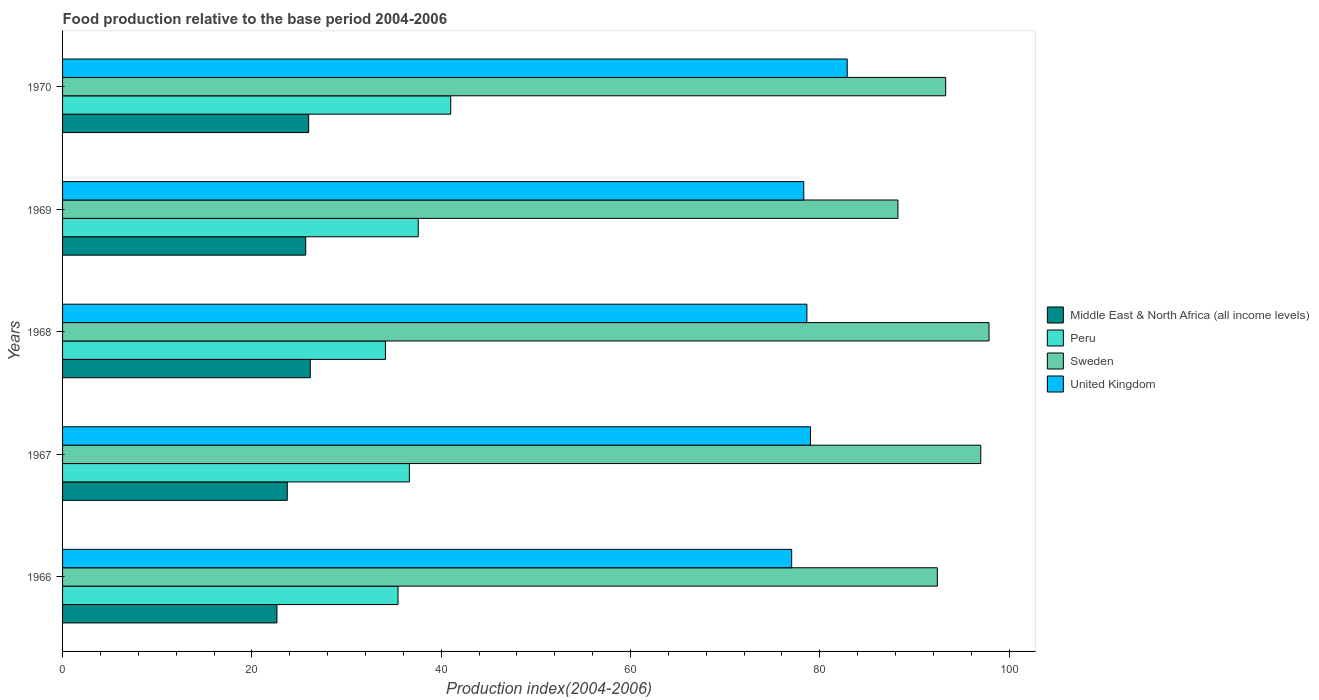Are the number of bars per tick equal to the number of legend labels?
Your answer should be very brief. Yes. Are the number of bars on each tick of the Y-axis equal?
Your response must be concise. Yes. How many bars are there on the 4th tick from the top?
Make the answer very short. 4. How many bars are there on the 2nd tick from the bottom?
Offer a very short reply. 4. What is the label of the 4th group of bars from the top?
Provide a succinct answer. 1967. What is the food production index in Peru in 1967?
Your response must be concise. 36.64. Across all years, what is the maximum food production index in Sweden?
Your response must be concise. 97.88. Across all years, what is the minimum food production index in Sweden?
Provide a succinct answer. 88.26. In which year was the food production index in Middle East & North Africa (all income levels) maximum?
Ensure brevity in your answer.  1968. In which year was the food production index in Sweden minimum?
Your answer should be compact. 1969. What is the total food production index in United Kingdom in the graph?
Your answer should be compact. 395.9. What is the difference between the food production index in Peru in 1966 and that in 1968?
Offer a very short reply. 1.33. What is the difference between the food production index in Peru in 1966 and the food production index in Sweden in 1967?
Ensure brevity in your answer.  -61.57. What is the average food production index in Peru per year?
Give a very brief answer. 36.96. In the year 1968, what is the difference between the food production index in United Kingdom and food production index in Sweden?
Give a very brief answer. -19.24. What is the ratio of the food production index in United Kingdom in 1967 to that in 1969?
Offer a terse response. 1.01. Is the difference between the food production index in United Kingdom in 1968 and 1969 greater than the difference between the food production index in Sweden in 1968 and 1969?
Offer a terse response. No. What is the difference between the highest and the second highest food production index in Middle East & North Africa (all income levels)?
Keep it short and to the point. 0.17. What is the difference between the highest and the lowest food production index in Peru?
Ensure brevity in your answer.  6.9. In how many years, is the food production index in United Kingdom greater than the average food production index in United Kingdom taken over all years?
Offer a very short reply. 1. Is the sum of the food production index in United Kingdom in 1966 and 1969 greater than the maximum food production index in Middle East & North Africa (all income levels) across all years?
Provide a short and direct response. Yes. What does the 3rd bar from the bottom in 1970 represents?
Your answer should be very brief. Sweden. How many bars are there?
Your response must be concise. 20. Are all the bars in the graph horizontal?
Provide a short and direct response. Yes. How many years are there in the graph?
Ensure brevity in your answer.  5. What is the difference between two consecutive major ticks on the X-axis?
Provide a succinct answer. 20. Does the graph contain any zero values?
Offer a terse response. No. How many legend labels are there?
Offer a very short reply. 4. What is the title of the graph?
Provide a short and direct response. Food production relative to the base period 2004-2006. Does "Palau" appear as one of the legend labels in the graph?
Your answer should be compact. No. What is the label or title of the X-axis?
Your answer should be very brief. Production index(2004-2006). What is the Production index(2004-2006) of Middle East & North Africa (all income levels) in 1966?
Make the answer very short. 22.65. What is the Production index(2004-2006) in Peru in 1966?
Make the answer very short. 35.44. What is the Production index(2004-2006) in Sweden in 1966?
Your answer should be very brief. 92.42. What is the Production index(2004-2006) in United Kingdom in 1966?
Offer a terse response. 77.03. What is the Production index(2004-2006) in Middle East & North Africa (all income levels) in 1967?
Offer a terse response. 23.74. What is the Production index(2004-2006) of Peru in 1967?
Your answer should be compact. 36.64. What is the Production index(2004-2006) of Sweden in 1967?
Provide a short and direct response. 97.01. What is the Production index(2004-2006) of United Kingdom in 1967?
Ensure brevity in your answer.  79.02. What is the Production index(2004-2006) of Middle East & North Africa (all income levels) in 1968?
Ensure brevity in your answer.  26.17. What is the Production index(2004-2006) in Peru in 1968?
Provide a succinct answer. 34.11. What is the Production index(2004-2006) in Sweden in 1968?
Your response must be concise. 97.88. What is the Production index(2004-2006) in United Kingdom in 1968?
Your response must be concise. 78.64. What is the Production index(2004-2006) in Middle East & North Africa (all income levels) in 1969?
Provide a succinct answer. 25.69. What is the Production index(2004-2006) of Peru in 1969?
Offer a very short reply. 37.58. What is the Production index(2004-2006) of Sweden in 1969?
Offer a very short reply. 88.26. What is the Production index(2004-2006) in United Kingdom in 1969?
Provide a short and direct response. 78.31. What is the Production index(2004-2006) in Middle East & North Africa (all income levels) in 1970?
Keep it short and to the point. 26. What is the Production index(2004-2006) in Peru in 1970?
Offer a very short reply. 41.01. What is the Production index(2004-2006) of Sweden in 1970?
Make the answer very short. 93.3. What is the Production index(2004-2006) in United Kingdom in 1970?
Give a very brief answer. 82.9. Across all years, what is the maximum Production index(2004-2006) in Middle East & North Africa (all income levels)?
Provide a short and direct response. 26.17. Across all years, what is the maximum Production index(2004-2006) in Peru?
Give a very brief answer. 41.01. Across all years, what is the maximum Production index(2004-2006) in Sweden?
Give a very brief answer. 97.88. Across all years, what is the maximum Production index(2004-2006) of United Kingdom?
Your answer should be compact. 82.9. Across all years, what is the minimum Production index(2004-2006) of Middle East & North Africa (all income levels)?
Give a very brief answer. 22.65. Across all years, what is the minimum Production index(2004-2006) of Peru?
Your response must be concise. 34.11. Across all years, what is the minimum Production index(2004-2006) in Sweden?
Make the answer very short. 88.26. Across all years, what is the minimum Production index(2004-2006) of United Kingdom?
Your answer should be compact. 77.03. What is the total Production index(2004-2006) in Middle East & North Africa (all income levels) in the graph?
Ensure brevity in your answer.  124.25. What is the total Production index(2004-2006) in Peru in the graph?
Offer a very short reply. 184.78. What is the total Production index(2004-2006) of Sweden in the graph?
Provide a succinct answer. 468.87. What is the total Production index(2004-2006) of United Kingdom in the graph?
Offer a terse response. 395.9. What is the difference between the Production index(2004-2006) in Middle East & North Africa (all income levels) in 1966 and that in 1967?
Ensure brevity in your answer.  -1.09. What is the difference between the Production index(2004-2006) of Sweden in 1966 and that in 1967?
Your answer should be compact. -4.59. What is the difference between the Production index(2004-2006) of United Kingdom in 1966 and that in 1967?
Your answer should be very brief. -1.99. What is the difference between the Production index(2004-2006) of Middle East & North Africa (all income levels) in 1966 and that in 1968?
Offer a very short reply. -3.52. What is the difference between the Production index(2004-2006) of Peru in 1966 and that in 1968?
Ensure brevity in your answer.  1.33. What is the difference between the Production index(2004-2006) of Sweden in 1966 and that in 1968?
Make the answer very short. -5.46. What is the difference between the Production index(2004-2006) in United Kingdom in 1966 and that in 1968?
Provide a short and direct response. -1.61. What is the difference between the Production index(2004-2006) of Middle East & North Africa (all income levels) in 1966 and that in 1969?
Offer a very short reply. -3.04. What is the difference between the Production index(2004-2006) of Peru in 1966 and that in 1969?
Your answer should be very brief. -2.14. What is the difference between the Production index(2004-2006) in Sweden in 1966 and that in 1969?
Your response must be concise. 4.16. What is the difference between the Production index(2004-2006) of United Kingdom in 1966 and that in 1969?
Provide a succinct answer. -1.28. What is the difference between the Production index(2004-2006) in Middle East & North Africa (all income levels) in 1966 and that in 1970?
Keep it short and to the point. -3.35. What is the difference between the Production index(2004-2006) of Peru in 1966 and that in 1970?
Your answer should be very brief. -5.57. What is the difference between the Production index(2004-2006) of Sweden in 1966 and that in 1970?
Make the answer very short. -0.88. What is the difference between the Production index(2004-2006) of United Kingdom in 1966 and that in 1970?
Keep it short and to the point. -5.87. What is the difference between the Production index(2004-2006) of Middle East & North Africa (all income levels) in 1967 and that in 1968?
Your answer should be compact. -2.43. What is the difference between the Production index(2004-2006) of Peru in 1967 and that in 1968?
Offer a very short reply. 2.53. What is the difference between the Production index(2004-2006) in Sweden in 1967 and that in 1968?
Your answer should be compact. -0.87. What is the difference between the Production index(2004-2006) of United Kingdom in 1967 and that in 1968?
Your answer should be compact. 0.38. What is the difference between the Production index(2004-2006) of Middle East & North Africa (all income levels) in 1967 and that in 1969?
Keep it short and to the point. -1.95. What is the difference between the Production index(2004-2006) in Peru in 1967 and that in 1969?
Provide a succinct answer. -0.94. What is the difference between the Production index(2004-2006) of Sweden in 1967 and that in 1969?
Offer a very short reply. 8.75. What is the difference between the Production index(2004-2006) of United Kingdom in 1967 and that in 1969?
Ensure brevity in your answer.  0.71. What is the difference between the Production index(2004-2006) of Middle East & North Africa (all income levels) in 1967 and that in 1970?
Provide a short and direct response. -2.26. What is the difference between the Production index(2004-2006) of Peru in 1967 and that in 1970?
Provide a succinct answer. -4.37. What is the difference between the Production index(2004-2006) of Sweden in 1967 and that in 1970?
Provide a succinct answer. 3.71. What is the difference between the Production index(2004-2006) in United Kingdom in 1967 and that in 1970?
Your answer should be very brief. -3.88. What is the difference between the Production index(2004-2006) in Middle East & North Africa (all income levels) in 1968 and that in 1969?
Provide a succinct answer. 0.48. What is the difference between the Production index(2004-2006) in Peru in 1968 and that in 1969?
Provide a succinct answer. -3.47. What is the difference between the Production index(2004-2006) in Sweden in 1968 and that in 1969?
Give a very brief answer. 9.62. What is the difference between the Production index(2004-2006) in United Kingdom in 1968 and that in 1969?
Your answer should be very brief. 0.33. What is the difference between the Production index(2004-2006) in Middle East & North Africa (all income levels) in 1968 and that in 1970?
Your answer should be compact. 0.17. What is the difference between the Production index(2004-2006) in Sweden in 1968 and that in 1970?
Offer a terse response. 4.58. What is the difference between the Production index(2004-2006) of United Kingdom in 1968 and that in 1970?
Provide a short and direct response. -4.26. What is the difference between the Production index(2004-2006) of Middle East & North Africa (all income levels) in 1969 and that in 1970?
Your answer should be compact. -0.31. What is the difference between the Production index(2004-2006) in Peru in 1969 and that in 1970?
Your answer should be compact. -3.43. What is the difference between the Production index(2004-2006) in Sweden in 1969 and that in 1970?
Give a very brief answer. -5.04. What is the difference between the Production index(2004-2006) in United Kingdom in 1969 and that in 1970?
Provide a succinct answer. -4.59. What is the difference between the Production index(2004-2006) in Middle East & North Africa (all income levels) in 1966 and the Production index(2004-2006) in Peru in 1967?
Keep it short and to the point. -13.99. What is the difference between the Production index(2004-2006) of Middle East & North Africa (all income levels) in 1966 and the Production index(2004-2006) of Sweden in 1967?
Provide a succinct answer. -74.36. What is the difference between the Production index(2004-2006) of Middle East & North Africa (all income levels) in 1966 and the Production index(2004-2006) of United Kingdom in 1967?
Your response must be concise. -56.37. What is the difference between the Production index(2004-2006) of Peru in 1966 and the Production index(2004-2006) of Sweden in 1967?
Make the answer very short. -61.57. What is the difference between the Production index(2004-2006) in Peru in 1966 and the Production index(2004-2006) in United Kingdom in 1967?
Provide a succinct answer. -43.58. What is the difference between the Production index(2004-2006) of Middle East & North Africa (all income levels) in 1966 and the Production index(2004-2006) of Peru in 1968?
Your response must be concise. -11.46. What is the difference between the Production index(2004-2006) in Middle East & North Africa (all income levels) in 1966 and the Production index(2004-2006) in Sweden in 1968?
Your response must be concise. -75.23. What is the difference between the Production index(2004-2006) of Middle East & North Africa (all income levels) in 1966 and the Production index(2004-2006) of United Kingdom in 1968?
Give a very brief answer. -55.99. What is the difference between the Production index(2004-2006) in Peru in 1966 and the Production index(2004-2006) in Sweden in 1968?
Provide a short and direct response. -62.44. What is the difference between the Production index(2004-2006) of Peru in 1966 and the Production index(2004-2006) of United Kingdom in 1968?
Offer a very short reply. -43.2. What is the difference between the Production index(2004-2006) of Sweden in 1966 and the Production index(2004-2006) of United Kingdom in 1968?
Provide a succinct answer. 13.78. What is the difference between the Production index(2004-2006) of Middle East & North Africa (all income levels) in 1966 and the Production index(2004-2006) of Peru in 1969?
Ensure brevity in your answer.  -14.93. What is the difference between the Production index(2004-2006) in Middle East & North Africa (all income levels) in 1966 and the Production index(2004-2006) in Sweden in 1969?
Give a very brief answer. -65.61. What is the difference between the Production index(2004-2006) in Middle East & North Africa (all income levels) in 1966 and the Production index(2004-2006) in United Kingdom in 1969?
Provide a short and direct response. -55.66. What is the difference between the Production index(2004-2006) of Peru in 1966 and the Production index(2004-2006) of Sweden in 1969?
Your answer should be compact. -52.82. What is the difference between the Production index(2004-2006) in Peru in 1966 and the Production index(2004-2006) in United Kingdom in 1969?
Your answer should be very brief. -42.87. What is the difference between the Production index(2004-2006) of Sweden in 1966 and the Production index(2004-2006) of United Kingdom in 1969?
Your response must be concise. 14.11. What is the difference between the Production index(2004-2006) in Middle East & North Africa (all income levels) in 1966 and the Production index(2004-2006) in Peru in 1970?
Give a very brief answer. -18.36. What is the difference between the Production index(2004-2006) in Middle East & North Africa (all income levels) in 1966 and the Production index(2004-2006) in Sweden in 1970?
Offer a very short reply. -70.65. What is the difference between the Production index(2004-2006) of Middle East & North Africa (all income levels) in 1966 and the Production index(2004-2006) of United Kingdom in 1970?
Provide a short and direct response. -60.25. What is the difference between the Production index(2004-2006) of Peru in 1966 and the Production index(2004-2006) of Sweden in 1970?
Give a very brief answer. -57.86. What is the difference between the Production index(2004-2006) in Peru in 1966 and the Production index(2004-2006) in United Kingdom in 1970?
Offer a terse response. -47.46. What is the difference between the Production index(2004-2006) of Sweden in 1966 and the Production index(2004-2006) of United Kingdom in 1970?
Provide a succinct answer. 9.52. What is the difference between the Production index(2004-2006) of Middle East & North Africa (all income levels) in 1967 and the Production index(2004-2006) of Peru in 1968?
Provide a short and direct response. -10.37. What is the difference between the Production index(2004-2006) of Middle East & North Africa (all income levels) in 1967 and the Production index(2004-2006) of Sweden in 1968?
Make the answer very short. -74.14. What is the difference between the Production index(2004-2006) of Middle East & North Africa (all income levels) in 1967 and the Production index(2004-2006) of United Kingdom in 1968?
Your answer should be compact. -54.9. What is the difference between the Production index(2004-2006) of Peru in 1967 and the Production index(2004-2006) of Sweden in 1968?
Your response must be concise. -61.24. What is the difference between the Production index(2004-2006) in Peru in 1967 and the Production index(2004-2006) in United Kingdom in 1968?
Offer a terse response. -42. What is the difference between the Production index(2004-2006) of Sweden in 1967 and the Production index(2004-2006) of United Kingdom in 1968?
Provide a succinct answer. 18.37. What is the difference between the Production index(2004-2006) in Middle East & North Africa (all income levels) in 1967 and the Production index(2004-2006) in Peru in 1969?
Your response must be concise. -13.84. What is the difference between the Production index(2004-2006) of Middle East & North Africa (all income levels) in 1967 and the Production index(2004-2006) of Sweden in 1969?
Provide a short and direct response. -64.52. What is the difference between the Production index(2004-2006) in Middle East & North Africa (all income levels) in 1967 and the Production index(2004-2006) in United Kingdom in 1969?
Your answer should be compact. -54.57. What is the difference between the Production index(2004-2006) in Peru in 1967 and the Production index(2004-2006) in Sweden in 1969?
Ensure brevity in your answer.  -51.62. What is the difference between the Production index(2004-2006) of Peru in 1967 and the Production index(2004-2006) of United Kingdom in 1969?
Keep it short and to the point. -41.67. What is the difference between the Production index(2004-2006) of Sweden in 1967 and the Production index(2004-2006) of United Kingdom in 1969?
Ensure brevity in your answer.  18.7. What is the difference between the Production index(2004-2006) of Middle East & North Africa (all income levels) in 1967 and the Production index(2004-2006) of Peru in 1970?
Provide a succinct answer. -17.27. What is the difference between the Production index(2004-2006) of Middle East & North Africa (all income levels) in 1967 and the Production index(2004-2006) of Sweden in 1970?
Your answer should be compact. -69.56. What is the difference between the Production index(2004-2006) in Middle East & North Africa (all income levels) in 1967 and the Production index(2004-2006) in United Kingdom in 1970?
Make the answer very short. -59.16. What is the difference between the Production index(2004-2006) in Peru in 1967 and the Production index(2004-2006) in Sweden in 1970?
Make the answer very short. -56.66. What is the difference between the Production index(2004-2006) in Peru in 1967 and the Production index(2004-2006) in United Kingdom in 1970?
Provide a succinct answer. -46.26. What is the difference between the Production index(2004-2006) of Sweden in 1967 and the Production index(2004-2006) of United Kingdom in 1970?
Give a very brief answer. 14.11. What is the difference between the Production index(2004-2006) in Middle East & North Africa (all income levels) in 1968 and the Production index(2004-2006) in Peru in 1969?
Your response must be concise. -11.41. What is the difference between the Production index(2004-2006) of Middle East & North Africa (all income levels) in 1968 and the Production index(2004-2006) of Sweden in 1969?
Offer a very short reply. -62.09. What is the difference between the Production index(2004-2006) in Middle East & North Africa (all income levels) in 1968 and the Production index(2004-2006) in United Kingdom in 1969?
Your answer should be very brief. -52.14. What is the difference between the Production index(2004-2006) of Peru in 1968 and the Production index(2004-2006) of Sweden in 1969?
Provide a short and direct response. -54.15. What is the difference between the Production index(2004-2006) of Peru in 1968 and the Production index(2004-2006) of United Kingdom in 1969?
Offer a terse response. -44.2. What is the difference between the Production index(2004-2006) in Sweden in 1968 and the Production index(2004-2006) in United Kingdom in 1969?
Your answer should be compact. 19.57. What is the difference between the Production index(2004-2006) of Middle East & North Africa (all income levels) in 1968 and the Production index(2004-2006) of Peru in 1970?
Make the answer very short. -14.84. What is the difference between the Production index(2004-2006) in Middle East & North Africa (all income levels) in 1968 and the Production index(2004-2006) in Sweden in 1970?
Provide a short and direct response. -67.13. What is the difference between the Production index(2004-2006) of Middle East & North Africa (all income levels) in 1968 and the Production index(2004-2006) of United Kingdom in 1970?
Make the answer very short. -56.73. What is the difference between the Production index(2004-2006) in Peru in 1968 and the Production index(2004-2006) in Sweden in 1970?
Your answer should be compact. -59.19. What is the difference between the Production index(2004-2006) in Peru in 1968 and the Production index(2004-2006) in United Kingdom in 1970?
Your answer should be compact. -48.79. What is the difference between the Production index(2004-2006) of Sweden in 1968 and the Production index(2004-2006) of United Kingdom in 1970?
Your response must be concise. 14.98. What is the difference between the Production index(2004-2006) in Middle East & North Africa (all income levels) in 1969 and the Production index(2004-2006) in Peru in 1970?
Make the answer very short. -15.32. What is the difference between the Production index(2004-2006) of Middle East & North Africa (all income levels) in 1969 and the Production index(2004-2006) of Sweden in 1970?
Your response must be concise. -67.61. What is the difference between the Production index(2004-2006) of Middle East & North Africa (all income levels) in 1969 and the Production index(2004-2006) of United Kingdom in 1970?
Give a very brief answer. -57.21. What is the difference between the Production index(2004-2006) in Peru in 1969 and the Production index(2004-2006) in Sweden in 1970?
Your response must be concise. -55.72. What is the difference between the Production index(2004-2006) of Peru in 1969 and the Production index(2004-2006) of United Kingdom in 1970?
Keep it short and to the point. -45.32. What is the difference between the Production index(2004-2006) in Sweden in 1969 and the Production index(2004-2006) in United Kingdom in 1970?
Give a very brief answer. 5.36. What is the average Production index(2004-2006) in Middle East & North Africa (all income levels) per year?
Keep it short and to the point. 24.85. What is the average Production index(2004-2006) in Peru per year?
Offer a terse response. 36.96. What is the average Production index(2004-2006) in Sweden per year?
Give a very brief answer. 93.77. What is the average Production index(2004-2006) of United Kingdom per year?
Your answer should be compact. 79.18. In the year 1966, what is the difference between the Production index(2004-2006) of Middle East & North Africa (all income levels) and Production index(2004-2006) of Peru?
Give a very brief answer. -12.79. In the year 1966, what is the difference between the Production index(2004-2006) in Middle East & North Africa (all income levels) and Production index(2004-2006) in Sweden?
Ensure brevity in your answer.  -69.77. In the year 1966, what is the difference between the Production index(2004-2006) of Middle East & North Africa (all income levels) and Production index(2004-2006) of United Kingdom?
Provide a short and direct response. -54.38. In the year 1966, what is the difference between the Production index(2004-2006) in Peru and Production index(2004-2006) in Sweden?
Ensure brevity in your answer.  -56.98. In the year 1966, what is the difference between the Production index(2004-2006) of Peru and Production index(2004-2006) of United Kingdom?
Offer a terse response. -41.59. In the year 1966, what is the difference between the Production index(2004-2006) of Sweden and Production index(2004-2006) of United Kingdom?
Offer a very short reply. 15.39. In the year 1967, what is the difference between the Production index(2004-2006) of Middle East & North Africa (all income levels) and Production index(2004-2006) of Peru?
Provide a short and direct response. -12.9. In the year 1967, what is the difference between the Production index(2004-2006) in Middle East & North Africa (all income levels) and Production index(2004-2006) in Sweden?
Your answer should be compact. -73.27. In the year 1967, what is the difference between the Production index(2004-2006) in Middle East & North Africa (all income levels) and Production index(2004-2006) in United Kingdom?
Offer a very short reply. -55.28. In the year 1967, what is the difference between the Production index(2004-2006) of Peru and Production index(2004-2006) of Sweden?
Your response must be concise. -60.37. In the year 1967, what is the difference between the Production index(2004-2006) of Peru and Production index(2004-2006) of United Kingdom?
Keep it short and to the point. -42.38. In the year 1967, what is the difference between the Production index(2004-2006) in Sweden and Production index(2004-2006) in United Kingdom?
Offer a very short reply. 17.99. In the year 1968, what is the difference between the Production index(2004-2006) in Middle East & North Africa (all income levels) and Production index(2004-2006) in Peru?
Keep it short and to the point. -7.94. In the year 1968, what is the difference between the Production index(2004-2006) of Middle East & North Africa (all income levels) and Production index(2004-2006) of Sweden?
Give a very brief answer. -71.71. In the year 1968, what is the difference between the Production index(2004-2006) in Middle East & North Africa (all income levels) and Production index(2004-2006) in United Kingdom?
Provide a short and direct response. -52.47. In the year 1968, what is the difference between the Production index(2004-2006) in Peru and Production index(2004-2006) in Sweden?
Keep it short and to the point. -63.77. In the year 1968, what is the difference between the Production index(2004-2006) of Peru and Production index(2004-2006) of United Kingdom?
Make the answer very short. -44.53. In the year 1968, what is the difference between the Production index(2004-2006) in Sweden and Production index(2004-2006) in United Kingdom?
Keep it short and to the point. 19.24. In the year 1969, what is the difference between the Production index(2004-2006) in Middle East & North Africa (all income levels) and Production index(2004-2006) in Peru?
Your answer should be compact. -11.89. In the year 1969, what is the difference between the Production index(2004-2006) in Middle East & North Africa (all income levels) and Production index(2004-2006) in Sweden?
Make the answer very short. -62.57. In the year 1969, what is the difference between the Production index(2004-2006) in Middle East & North Africa (all income levels) and Production index(2004-2006) in United Kingdom?
Your answer should be compact. -52.62. In the year 1969, what is the difference between the Production index(2004-2006) of Peru and Production index(2004-2006) of Sweden?
Provide a short and direct response. -50.68. In the year 1969, what is the difference between the Production index(2004-2006) of Peru and Production index(2004-2006) of United Kingdom?
Offer a very short reply. -40.73. In the year 1969, what is the difference between the Production index(2004-2006) in Sweden and Production index(2004-2006) in United Kingdom?
Your answer should be compact. 9.95. In the year 1970, what is the difference between the Production index(2004-2006) of Middle East & North Africa (all income levels) and Production index(2004-2006) of Peru?
Offer a very short reply. -15.01. In the year 1970, what is the difference between the Production index(2004-2006) in Middle East & North Africa (all income levels) and Production index(2004-2006) in Sweden?
Your answer should be very brief. -67.3. In the year 1970, what is the difference between the Production index(2004-2006) in Middle East & North Africa (all income levels) and Production index(2004-2006) in United Kingdom?
Ensure brevity in your answer.  -56.9. In the year 1970, what is the difference between the Production index(2004-2006) in Peru and Production index(2004-2006) in Sweden?
Provide a succinct answer. -52.29. In the year 1970, what is the difference between the Production index(2004-2006) in Peru and Production index(2004-2006) in United Kingdom?
Offer a very short reply. -41.89. What is the ratio of the Production index(2004-2006) in Middle East & North Africa (all income levels) in 1966 to that in 1967?
Make the answer very short. 0.95. What is the ratio of the Production index(2004-2006) in Peru in 1966 to that in 1967?
Ensure brevity in your answer.  0.97. What is the ratio of the Production index(2004-2006) in Sweden in 1966 to that in 1967?
Provide a succinct answer. 0.95. What is the ratio of the Production index(2004-2006) of United Kingdom in 1966 to that in 1967?
Offer a very short reply. 0.97. What is the ratio of the Production index(2004-2006) of Middle East & North Africa (all income levels) in 1966 to that in 1968?
Give a very brief answer. 0.87. What is the ratio of the Production index(2004-2006) in Peru in 1966 to that in 1968?
Make the answer very short. 1.04. What is the ratio of the Production index(2004-2006) of Sweden in 1966 to that in 1968?
Your response must be concise. 0.94. What is the ratio of the Production index(2004-2006) of United Kingdom in 1966 to that in 1968?
Your answer should be compact. 0.98. What is the ratio of the Production index(2004-2006) of Middle East & North Africa (all income levels) in 1966 to that in 1969?
Provide a short and direct response. 0.88. What is the ratio of the Production index(2004-2006) of Peru in 1966 to that in 1969?
Keep it short and to the point. 0.94. What is the ratio of the Production index(2004-2006) of Sweden in 1966 to that in 1969?
Offer a terse response. 1.05. What is the ratio of the Production index(2004-2006) in United Kingdom in 1966 to that in 1969?
Provide a succinct answer. 0.98. What is the ratio of the Production index(2004-2006) of Middle East & North Africa (all income levels) in 1966 to that in 1970?
Your answer should be compact. 0.87. What is the ratio of the Production index(2004-2006) of Peru in 1966 to that in 1970?
Your response must be concise. 0.86. What is the ratio of the Production index(2004-2006) of Sweden in 1966 to that in 1970?
Your answer should be very brief. 0.99. What is the ratio of the Production index(2004-2006) of United Kingdom in 1966 to that in 1970?
Provide a succinct answer. 0.93. What is the ratio of the Production index(2004-2006) in Middle East & North Africa (all income levels) in 1967 to that in 1968?
Give a very brief answer. 0.91. What is the ratio of the Production index(2004-2006) of Peru in 1967 to that in 1968?
Keep it short and to the point. 1.07. What is the ratio of the Production index(2004-2006) of Middle East & North Africa (all income levels) in 1967 to that in 1969?
Give a very brief answer. 0.92. What is the ratio of the Production index(2004-2006) of Sweden in 1967 to that in 1969?
Your response must be concise. 1.1. What is the ratio of the Production index(2004-2006) in United Kingdom in 1967 to that in 1969?
Your response must be concise. 1.01. What is the ratio of the Production index(2004-2006) of Middle East & North Africa (all income levels) in 1967 to that in 1970?
Offer a terse response. 0.91. What is the ratio of the Production index(2004-2006) in Peru in 1967 to that in 1970?
Give a very brief answer. 0.89. What is the ratio of the Production index(2004-2006) in Sweden in 1967 to that in 1970?
Offer a very short reply. 1.04. What is the ratio of the Production index(2004-2006) of United Kingdom in 1967 to that in 1970?
Your answer should be compact. 0.95. What is the ratio of the Production index(2004-2006) in Middle East & North Africa (all income levels) in 1968 to that in 1969?
Provide a short and direct response. 1.02. What is the ratio of the Production index(2004-2006) in Peru in 1968 to that in 1969?
Keep it short and to the point. 0.91. What is the ratio of the Production index(2004-2006) in Sweden in 1968 to that in 1969?
Make the answer very short. 1.11. What is the ratio of the Production index(2004-2006) in United Kingdom in 1968 to that in 1969?
Keep it short and to the point. 1. What is the ratio of the Production index(2004-2006) of Peru in 1968 to that in 1970?
Make the answer very short. 0.83. What is the ratio of the Production index(2004-2006) in Sweden in 1968 to that in 1970?
Provide a succinct answer. 1.05. What is the ratio of the Production index(2004-2006) of United Kingdom in 1968 to that in 1970?
Ensure brevity in your answer.  0.95. What is the ratio of the Production index(2004-2006) in Peru in 1969 to that in 1970?
Ensure brevity in your answer.  0.92. What is the ratio of the Production index(2004-2006) in Sweden in 1969 to that in 1970?
Your response must be concise. 0.95. What is the ratio of the Production index(2004-2006) of United Kingdom in 1969 to that in 1970?
Your answer should be very brief. 0.94. What is the difference between the highest and the second highest Production index(2004-2006) of Middle East & North Africa (all income levels)?
Offer a terse response. 0.17. What is the difference between the highest and the second highest Production index(2004-2006) in Peru?
Give a very brief answer. 3.43. What is the difference between the highest and the second highest Production index(2004-2006) in Sweden?
Ensure brevity in your answer.  0.87. What is the difference between the highest and the second highest Production index(2004-2006) of United Kingdom?
Make the answer very short. 3.88. What is the difference between the highest and the lowest Production index(2004-2006) in Middle East & North Africa (all income levels)?
Ensure brevity in your answer.  3.52. What is the difference between the highest and the lowest Production index(2004-2006) of Sweden?
Ensure brevity in your answer.  9.62. What is the difference between the highest and the lowest Production index(2004-2006) in United Kingdom?
Offer a terse response. 5.87. 